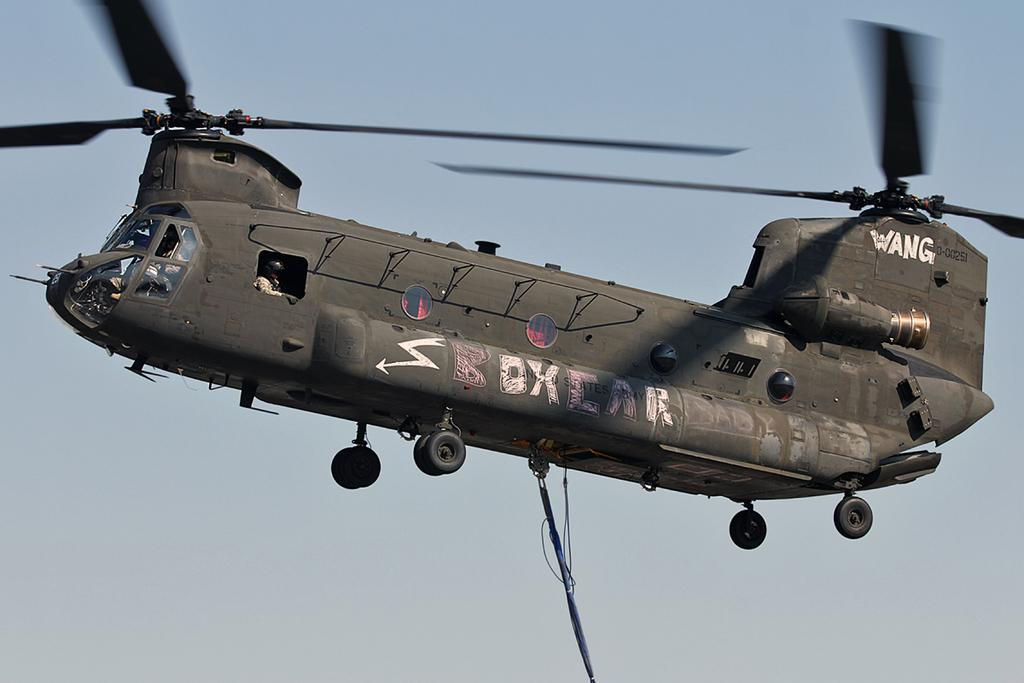Provide a one-sentence caption for the provided image. A grey Wang helicopter is soaring through the sky. 